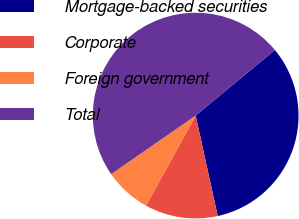Convert chart. <chart><loc_0><loc_0><loc_500><loc_500><pie_chart><fcel>Mortgage-backed securities<fcel>Corporate<fcel>Foreign government<fcel>Total<nl><fcel>32.57%<fcel>11.46%<fcel>7.33%<fcel>48.63%<nl></chart> 